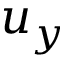<formula> <loc_0><loc_0><loc_500><loc_500>u _ { y }</formula> 